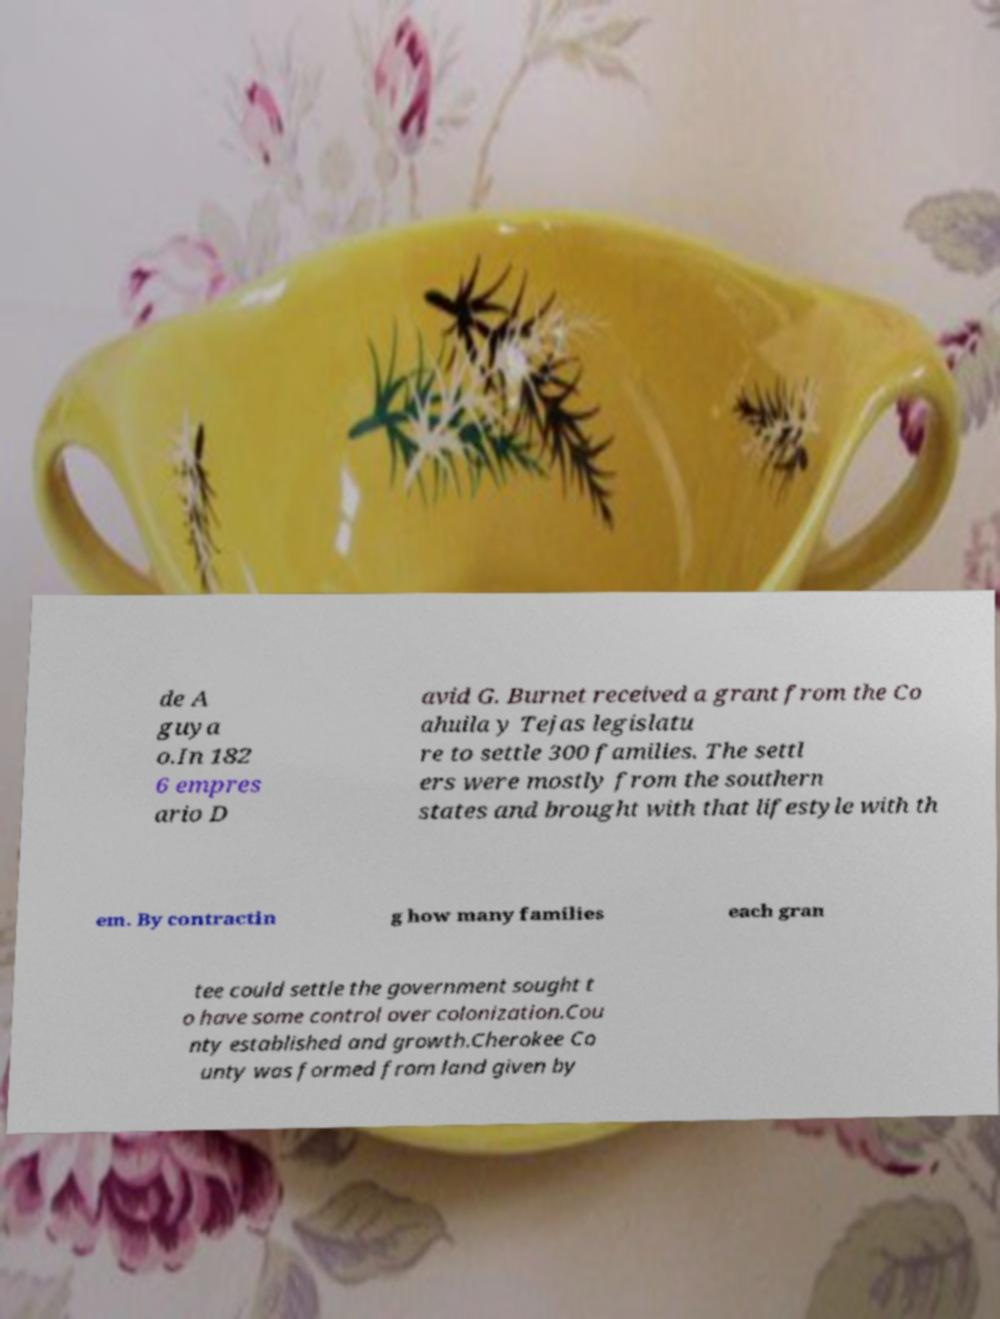There's text embedded in this image that I need extracted. Can you transcribe it verbatim? de A guya o.In 182 6 empres ario D avid G. Burnet received a grant from the Co ahuila y Tejas legislatu re to settle 300 families. The settl ers were mostly from the southern states and brought with that lifestyle with th em. By contractin g how many families each gran tee could settle the government sought t o have some control over colonization.Cou nty established and growth.Cherokee Co unty was formed from land given by 